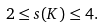Convert formula to latex. <formula><loc_0><loc_0><loc_500><loc_500>2 \leq s ( K ) \leq 4 .</formula> 